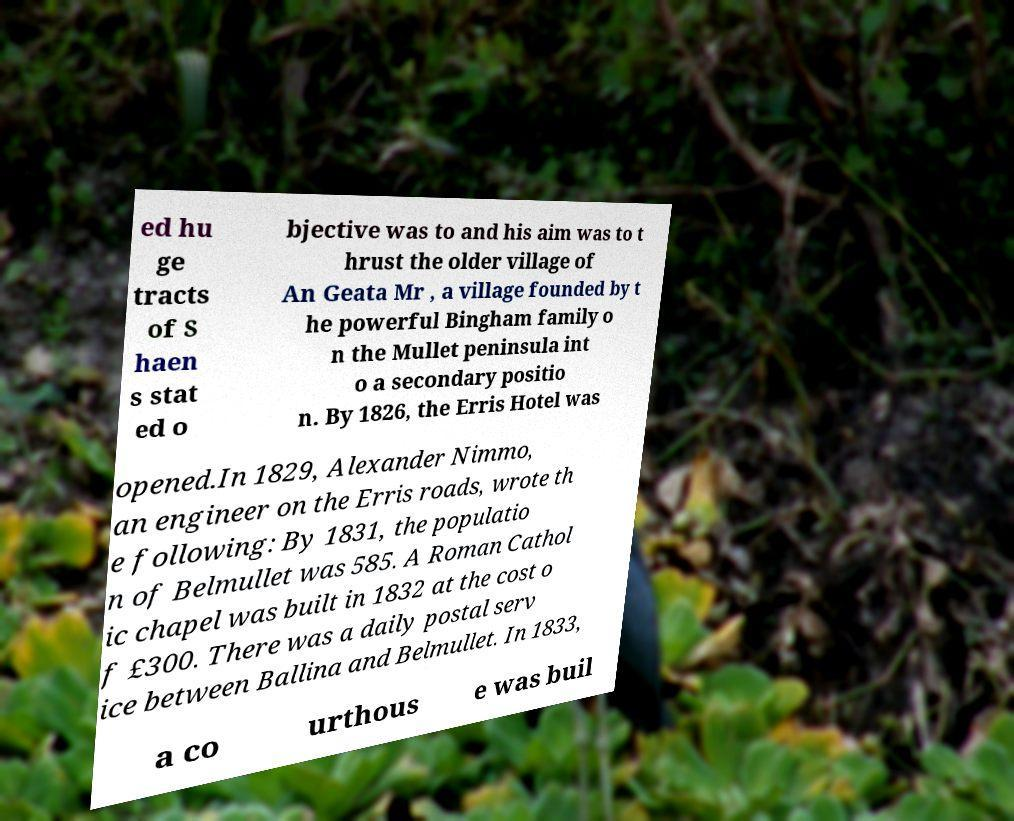Can you read and provide the text displayed in the image?This photo seems to have some interesting text. Can you extract and type it out for me? ed hu ge tracts of S haen s stat ed o bjective was to and his aim was to t hrust the older village of An Geata Mr , a village founded by t he powerful Bingham family o n the Mullet peninsula int o a secondary positio n. By 1826, the Erris Hotel was opened.In 1829, Alexander Nimmo, an engineer on the Erris roads, wrote th e following: By 1831, the populatio n of Belmullet was 585. A Roman Cathol ic chapel was built in 1832 at the cost o f £300. There was a daily postal serv ice between Ballina and Belmullet. In 1833, a co urthous e was buil 